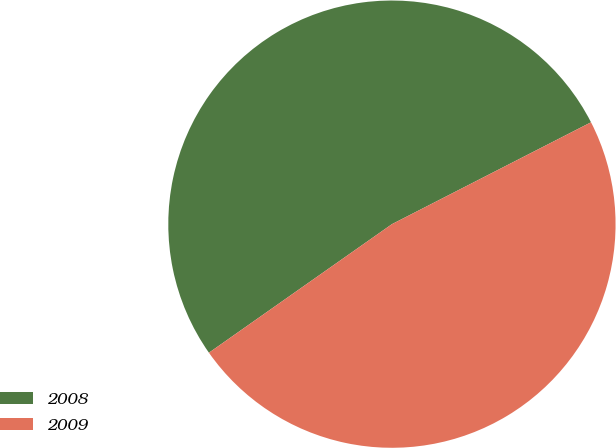Convert chart to OTSL. <chart><loc_0><loc_0><loc_500><loc_500><pie_chart><fcel>2008<fcel>2009<nl><fcel>52.22%<fcel>47.78%<nl></chart> 